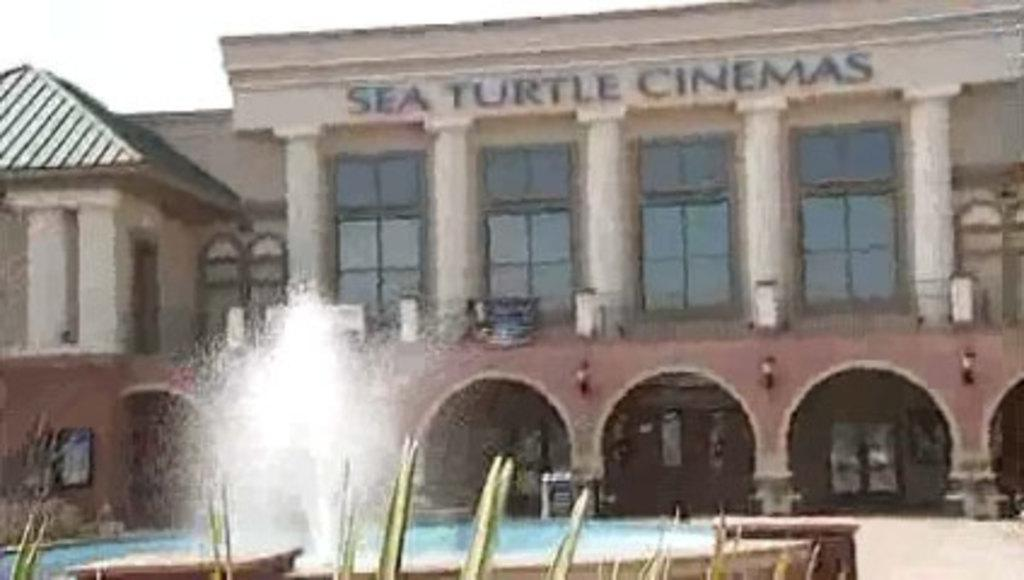What type of structure is present in the image? There is a building in the image. What feature of the building is mentioned in the facts? The building has glass doors and pillars. Is there any signage on the building? Yes, there is a name board on the building. What other element can be seen at the bottom of the image? There is a water fountain at the bottom of the image. What type of natural elements are visible in the image? There are leaves visible in the image. What color is the lead crayon used by the creature in the image? There is no lead crayon or creature present in the image. 